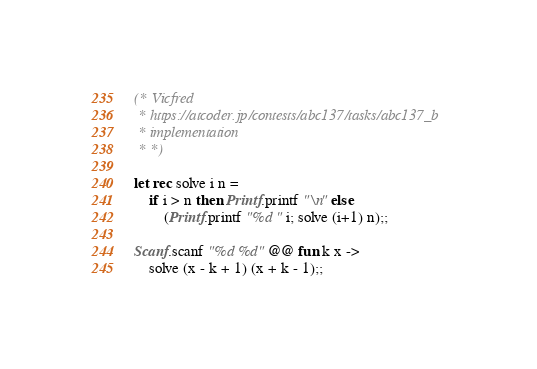<code> <loc_0><loc_0><loc_500><loc_500><_OCaml_>(* Vicfred
 * https://atcoder.jp/contests/abc137/tasks/abc137_b
 * implementation
 * *)

let rec solve i n =
    if i > n then Printf.printf "\n" else
        (Printf.printf "%d " i; solve (i+1) n);;

Scanf.scanf "%d %d" @@ fun k x ->
    solve (x - k + 1) (x + k - 1);;

</code> 